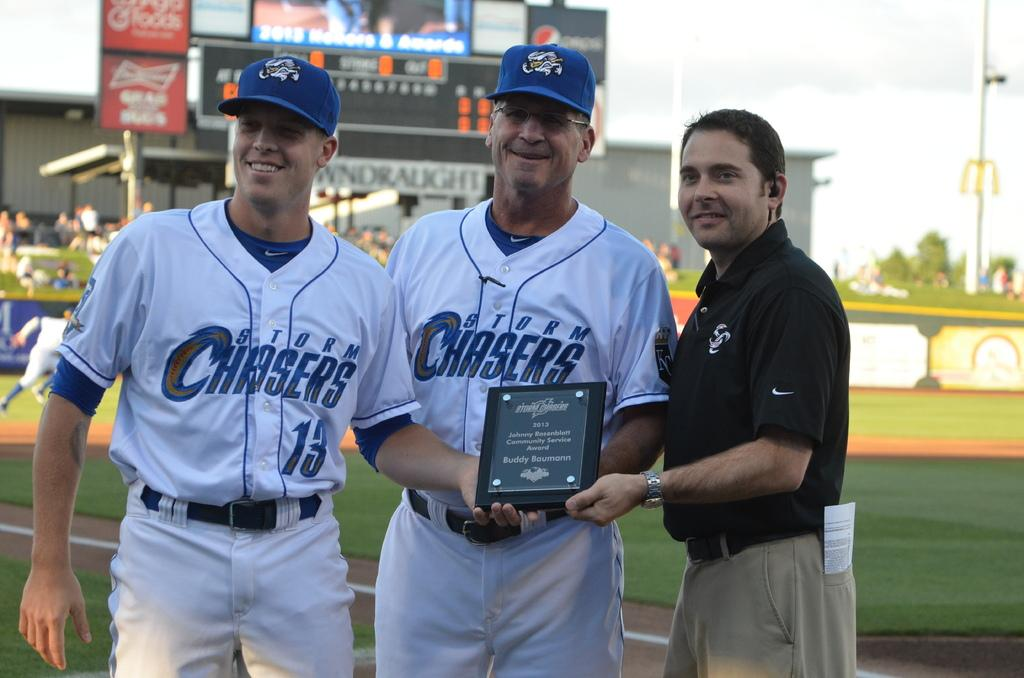<image>
Give a short and clear explanation of the subsequent image. Two baseball players wearing Storm Chasers team shirts are accepting an award on the ball field. 